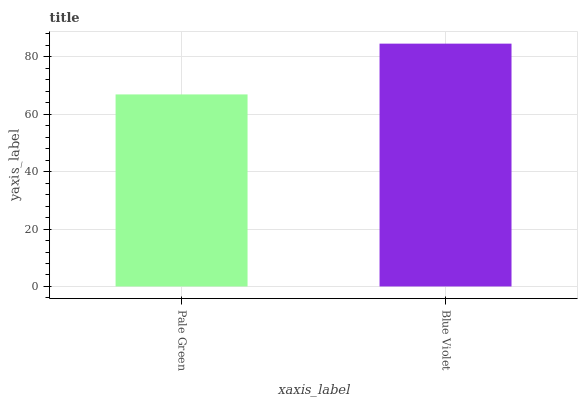Is Pale Green the minimum?
Answer yes or no. Yes. Is Blue Violet the maximum?
Answer yes or no. Yes. Is Blue Violet the minimum?
Answer yes or no. No. Is Blue Violet greater than Pale Green?
Answer yes or no. Yes. Is Pale Green less than Blue Violet?
Answer yes or no. Yes. Is Pale Green greater than Blue Violet?
Answer yes or no. No. Is Blue Violet less than Pale Green?
Answer yes or no. No. Is Blue Violet the high median?
Answer yes or no. Yes. Is Pale Green the low median?
Answer yes or no. Yes. Is Pale Green the high median?
Answer yes or no. No. Is Blue Violet the low median?
Answer yes or no. No. 